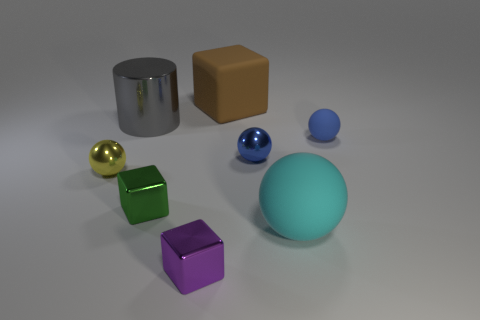What number of other objects are the same size as the brown matte block?
Give a very brief answer. 2. Are there more tiny green rubber things than small cubes?
Offer a terse response. No. What number of big matte things are behind the large gray metallic cylinder and right of the big brown matte object?
Ensure brevity in your answer.  0. What shape is the large matte thing on the left side of the large thing that is in front of the metallic ball in front of the tiny blue metal object?
Your answer should be very brief. Cube. Is there anything else that is the same shape as the large metallic thing?
Provide a short and direct response. No. How many cylinders are either tiny brown rubber objects or green things?
Provide a short and direct response. 0. There is a metal cube that is behind the cyan rubber object; is it the same color as the big metallic object?
Your answer should be very brief. No. What is the material of the big object in front of the small metallic sphere to the left of the large gray cylinder to the right of the yellow sphere?
Provide a short and direct response. Rubber. Is the green metallic cube the same size as the gray cylinder?
Your answer should be very brief. No. Is the color of the large cylinder the same as the tiny sphere that is to the left of the big metallic thing?
Offer a very short reply. No. 